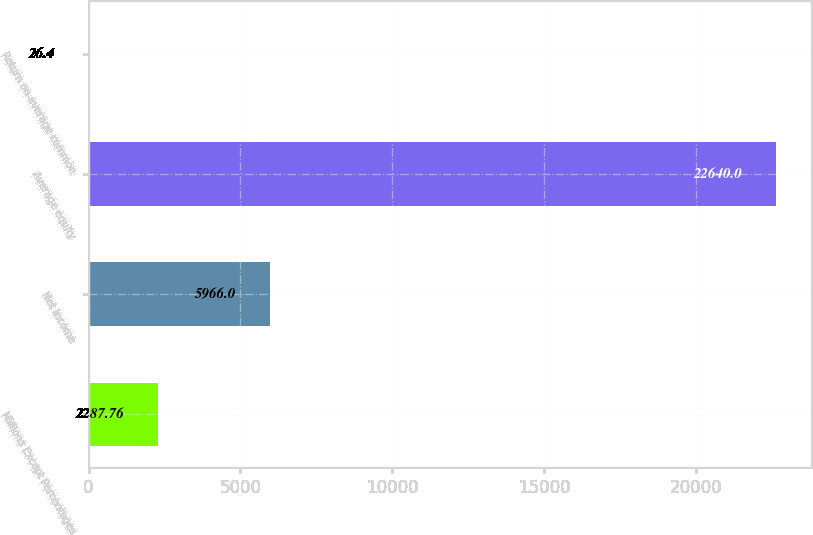<chart> <loc_0><loc_0><loc_500><loc_500><bar_chart><fcel>Millions Except Percentages<fcel>Net income<fcel>Average equity<fcel>Return on average common<nl><fcel>2287.76<fcel>5966<fcel>22640<fcel>26.4<nl></chart> 